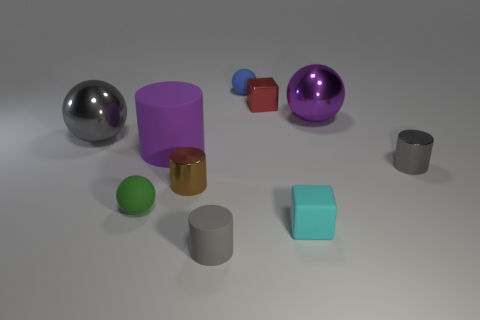Subtract all tiny matte cylinders. How many cylinders are left? 3 Subtract all green spheres. How many spheres are left? 3 Subtract all spheres. How many objects are left? 6 Add 1 tiny cyan metal objects. How many tiny cyan metal objects exist? 1 Subtract 1 green spheres. How many objects are left? 9 Subtract 1 cubes. How many cubes are left? 1 Subtract all red blocks. Subtract all brown cylinders. How many blocks are left? 1 Subtract all purple cylinders. How many brown cubes are left? 0 Subtract all big gray spheres. Subtract all large purple cubes. How many objects are left? 9 Add 8 tiny gray cylinders. How many tiny gray cylinders are left? 10 